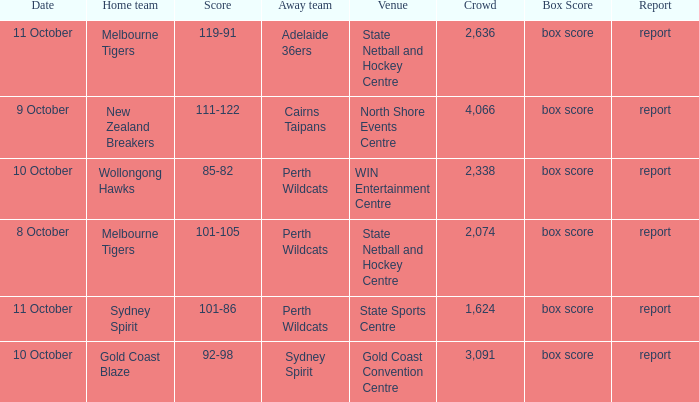What was the crowd size for the game with a score of 101-105? 2074.0. 